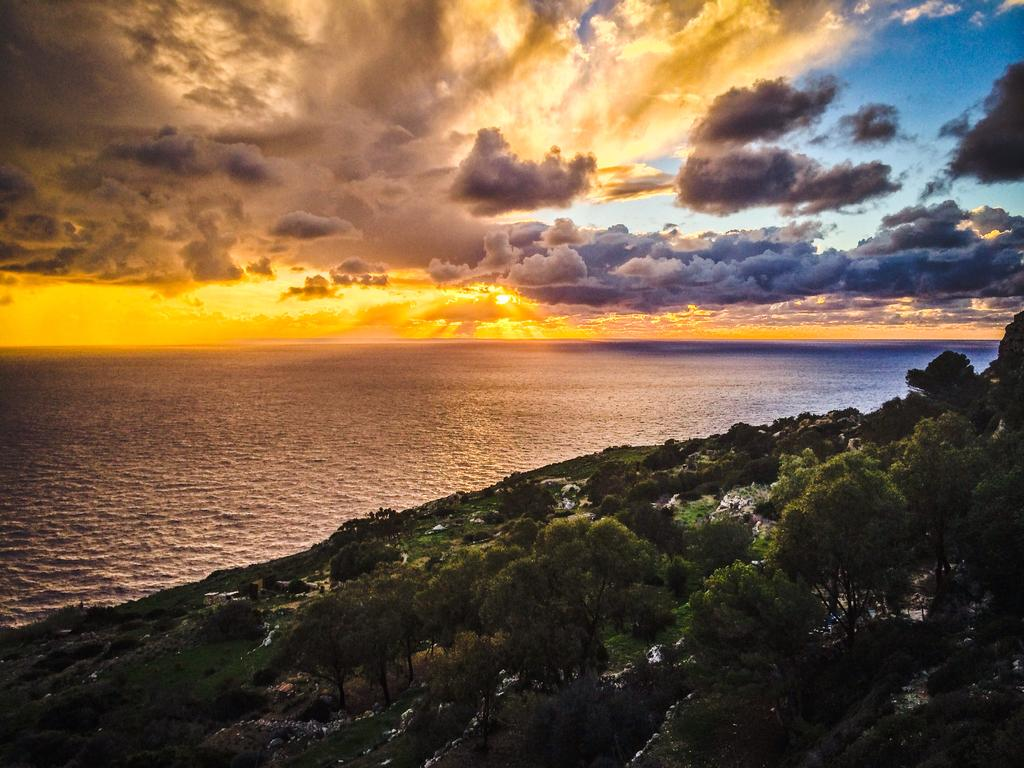What type of landform is located on the right side of the image? There is a hill on the right side of the image. What can be seen on the hill? There are many trees on the hill. What body of water is visible on the left side of the image? There appears to be an ocean on the left side of the image. What is visible at the top of the image? The sky is visible at the top of the image. What can be observed in the sky? Clouds are present in the sky. Can you tell me how many sails are visible on the ocean in the image? There are no sails visible on the ocean in the image. What type of porter is carrying the trees on the hill? There is no porter present in the image, and the trees are not being carried by anyone. 